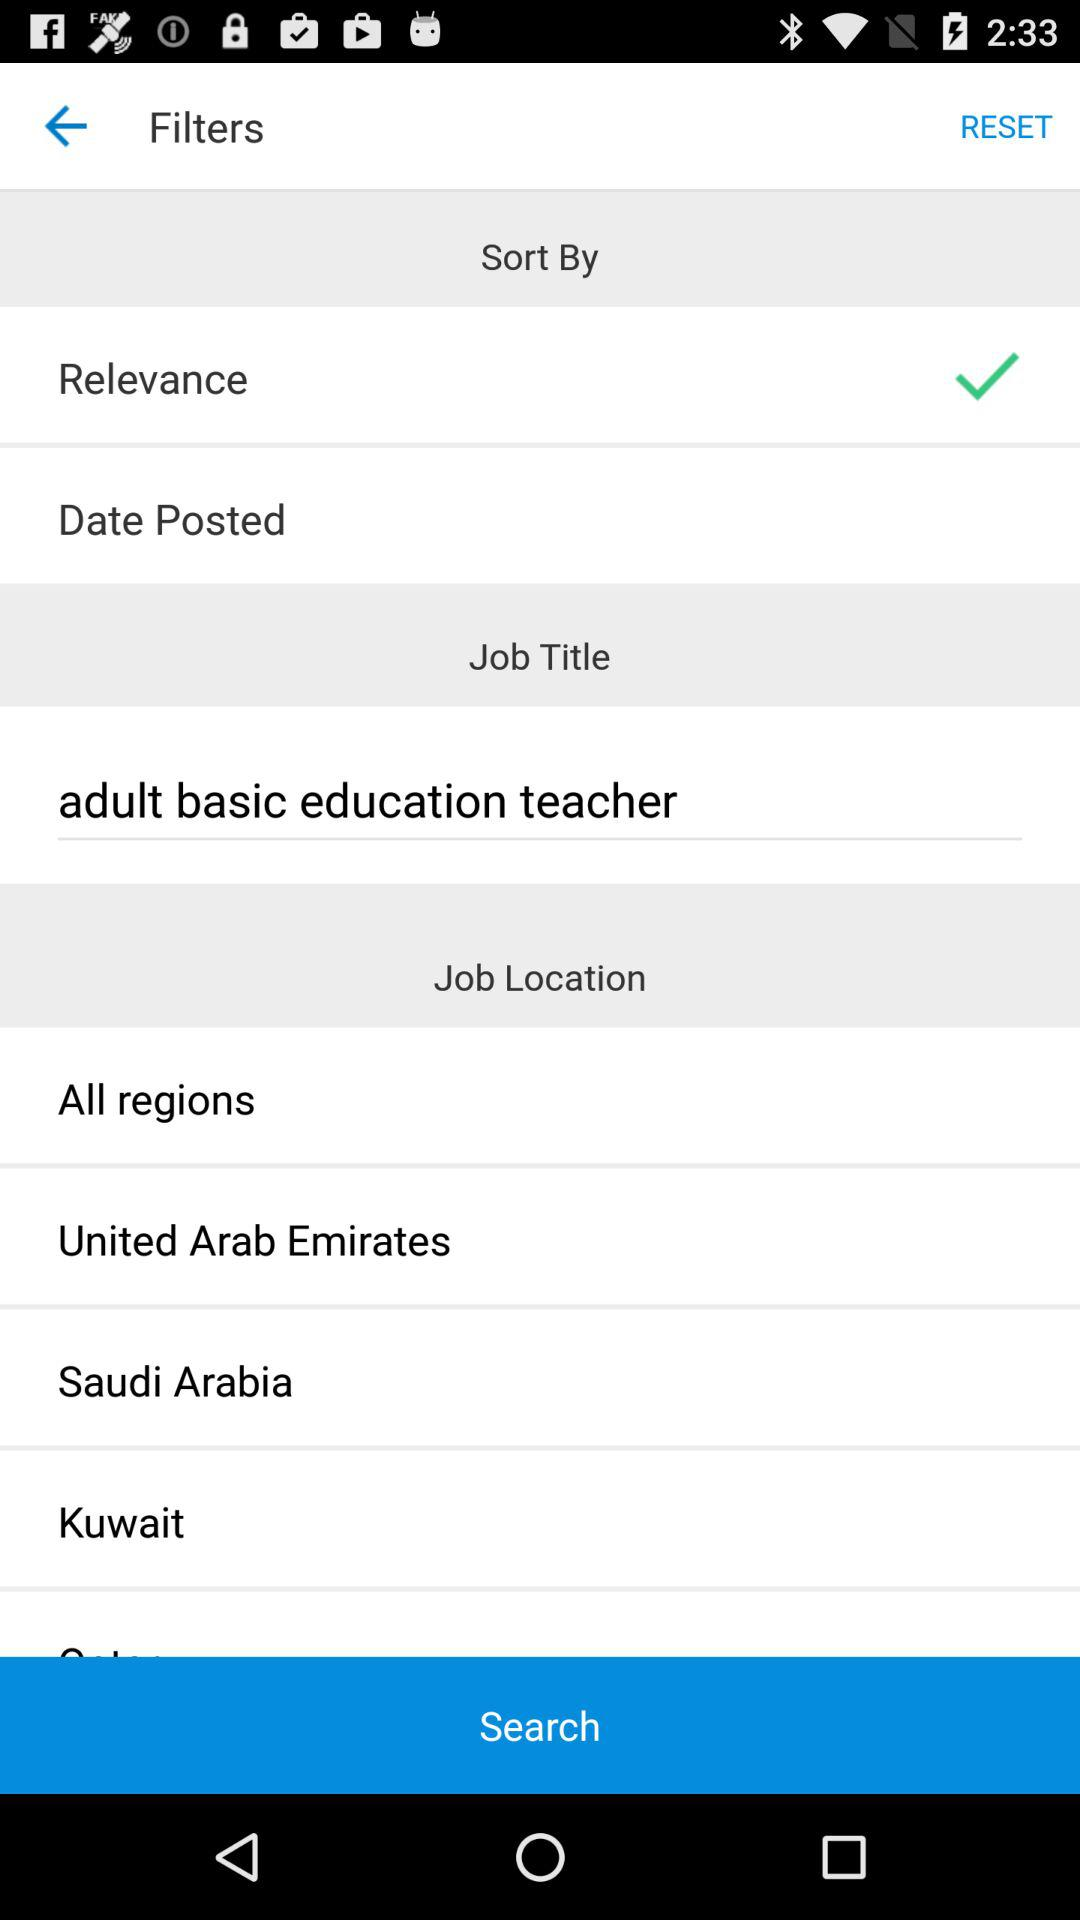Which option is selected for "Sort By"? The selected option is "Relevance". 